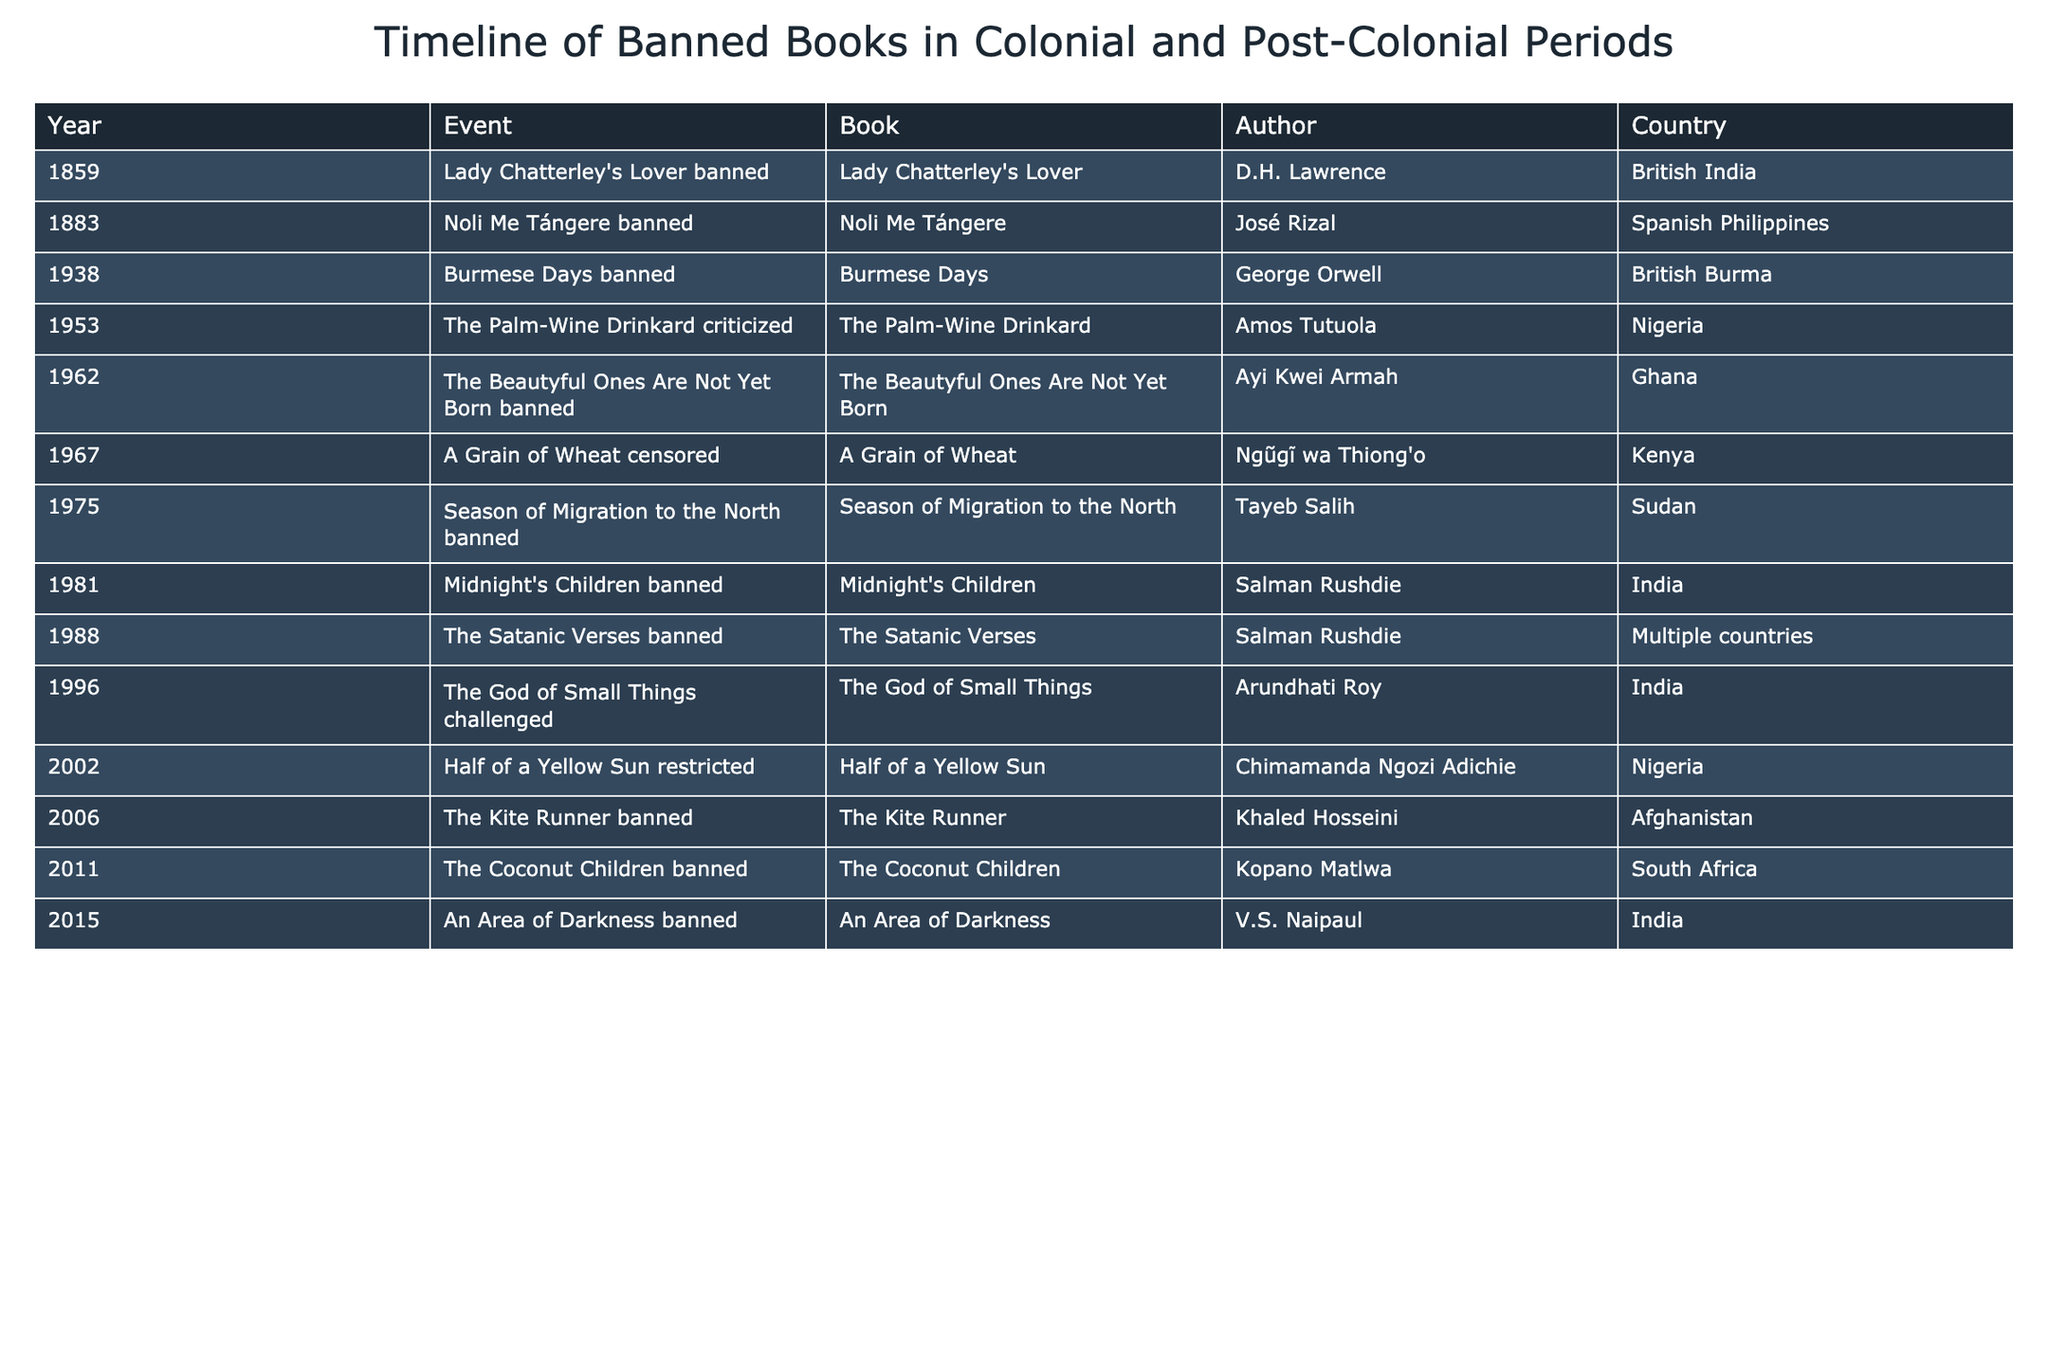What year was "A Grain of Wheat" censored? The table states that "A Grain of Wheat" was censored in the year 1967.
Answer: 1967 Which book by Salman Rushdie was banned in multiple countries? The table lists "The Satanic Verses" as the book by Salman Rushdie that was banned in multiple countries in the year 1988.
Answer: The Satanic Verses How many books were banned in the 1960s? From the table, the books banned in the 1960s are "The Beautyful Ones Are Not Yet Born" (1962) and "A Grain of Wheat" (1967). Therefore, there are 2 banned books in that decade.
Answer: 2 Is "The God of Small Things" challenged? Referring to the table, it shows that "The God of Small Things" is indeed challenged, so the answer is yes.
Answer: Yes What is the chronological order of the first three banned books listed? The first three banned books according to the table, in chronological order, are "Lady Chatterley's Lover" (1859), "Noli Me Tángere" (1883), and "Burmese Days" (1938).
Answer: Lady Chatterley's Lover, Noli Me Tángere, Burmese Days How many books were banned after 2000? The table indicates that there are three books banned after the year 2000: "The Coconut Children" (2011), "An Area of Darkness" (2015), and "Half of a Yellow Sun" (2002). Adding all gives a total of 3 banned books after 2000.
Answer: 3 Which country had the highest number of banned books listed in the table? By evaluating the table, both India and Nigeria appear multiple times, but Nigeria has 2 banned books whereas India has 3: "Midnight's Children," "The God of Small Things," and "An Area of Darkness." Thus, India has the highest number of banned books listed.
Answer: India Did any of the banned books originate from Afghanistan? Looking at the table, "The Kite Runner" is mentioned as banned and it is from Afghanistan. Therefore, the answer is yes.
Answer: Yes 